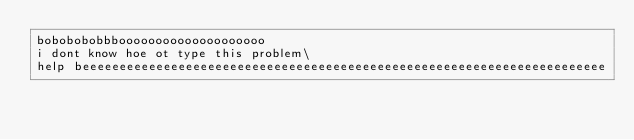<code> <loc_0><loc_0><loc_500><loc_500><_Python_>bobobobobbboooooooooooooooooooo
i dont know hoe ot type this problem\
help beeeeeeeeeeeeeeeeeeeeeeeeeeeeeeeeeeeeeeeeeeeeeeeeeeeeeeeeeeeeeeeeeeeeeee
</code> 